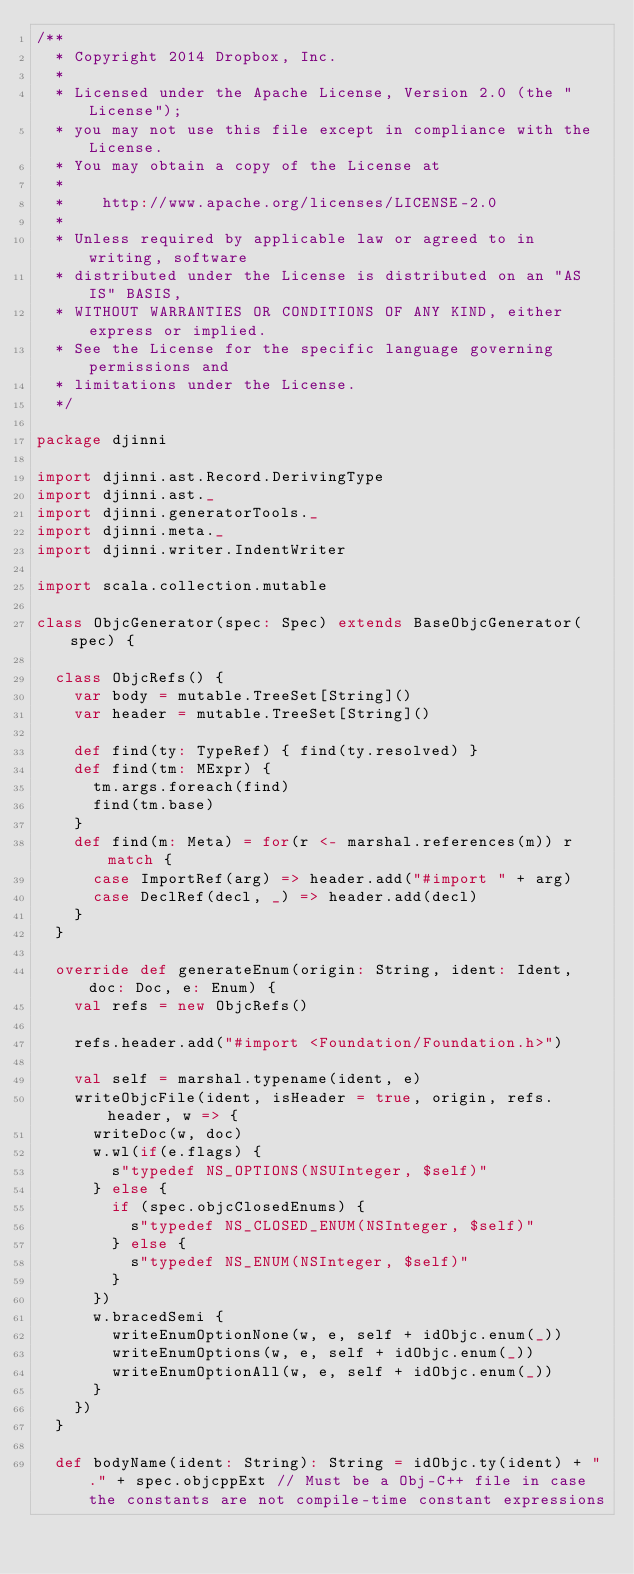Convert code to text. <code><loc_0><loc_0><loc_500><loc_500><_Scala_>/**
  * Copyright 2014 Dropbox, Inc.
  *
  * Licensed under the Apache License, Version 2.0 (the "License");
  * you may not use this file except in compliance with the License.
  * You may obtain a copy of the License at
  *
  *    http://www.apache.org/licenses/LICENSE-2.0
  *
  * Unless required by applicable law or agreed to in writing, software
  * distributed under the License is distributed on an "AS IS" BASIS,
  * WITHOUT WARRANTIES OR CONDITIONS OF ANY KIND, either express or implied.
  * See the License for the specific language governing permissions and
  * limitations under the License.
  */

package djinni

import djinni.ast.Record.DerivingType
import djinni.ast._
import djinni.generatorTools._
import djinni.meta._
import djinni.writer.IndentWriter

import scala.collection.mutable

class ObjcGenerator(spec: Spec) extends BaseObjcGenerator(spec) {

  class ObjcRefs() {
    var body = mutable.TreeSet[String]()
    var header = mutable.TreeSet[String]()

    def find(ty: TypeRef) { find(ty.resolved) }
    def find(tm: MExpr) {
      tm.args.foreach(find)
      find(tm.base)
    }
    def find(m: Meta) = for(r <- marshal.references(m)) r match {
      case ImportRef(arg) => header.add("#import " + arg)
      case DeclRef(decl, _) => header.add(decl)
    }
  }

  override def generateEnum(origin: String, ident: Ident, doc: Doc, e: Enum) {
    val refs = new ObjcRefs()

    refs.header.add("#import <Foundation/Foundation.h>")

    val self = marshal.typename(ident, e)
    writeObjcFile(ident, isHeader = true, origin, refs.header, w => {
      writeDoc(w, doc)
      w.wl(if(e.flags) {
        s"typedef NS_OPTIONS(NSUInteger, $self)"
      } else {
        if (spec.objcClosedEnums) {
          s"typedef NS_CLOSED_ENUM(NSInteger, $self)"
        } else {
          s"typedef NS_ENUM(NSInteger, $self)"
        }
      })
      w.bracedSemi {
        writeEnumOptionNone(w, e, self + idObjc.enum(_))
        writeEnumOptions(w, e, self + idObjc.enum(_))
        writeEnumOptionAll(w, e, self + idObjc.enum(_))
      }
    })
  }

  def bodyName(ident: String): String = idObjc.ty(ident) + "." + spec.objcppExt // Must be a Obj-C++ file in case the constants are not compile-time constant expressions
</code> 